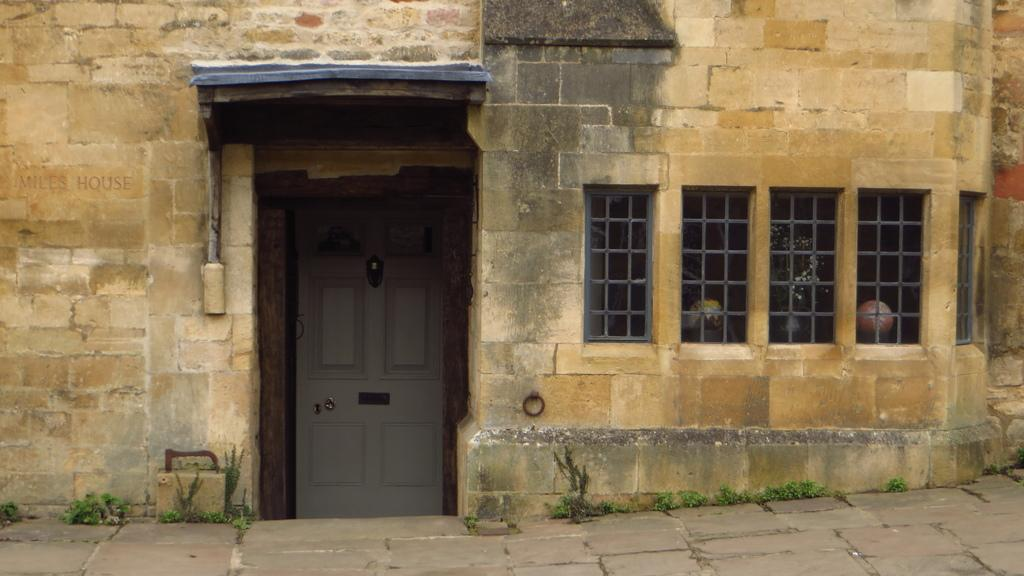What type of surface is visible in the image? There is ground visible in the image. What other elements can be seen in the image besides the ground? There are plants and a brown and black building in the image. What features does the building have? The building has windows and a white-colored door. What type of flag is flying above the building in the image? There is no flag visible in the image. What country is represented by the flag flying above the building in the image? As there is no flag present in the image, it is impossible to determine which country it might represent. 